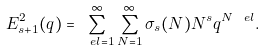<formula> <loc_0><loc_0><loc_500><loc_500>E _ { s + 1 } ^ { 2 } ( q ) = \sum _ { \ e l = 1 } ^ { \infty } \sum _ { N = 1 } ^ { \infty } \sigma _ { s } ( N ) N ^ { s } q ^ { N \ e l } .</formula> 